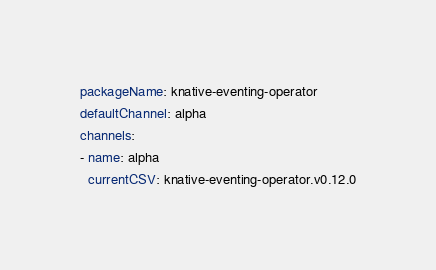<code> <loc_0><loc_0><loc_500><loc_500><_YAML_>packageName: knative-eventing-operator
defaultChannel: alpha
channels:
- name: alpha
  currentCSV: knative-eventing-operator.v0.12.0
</code> 